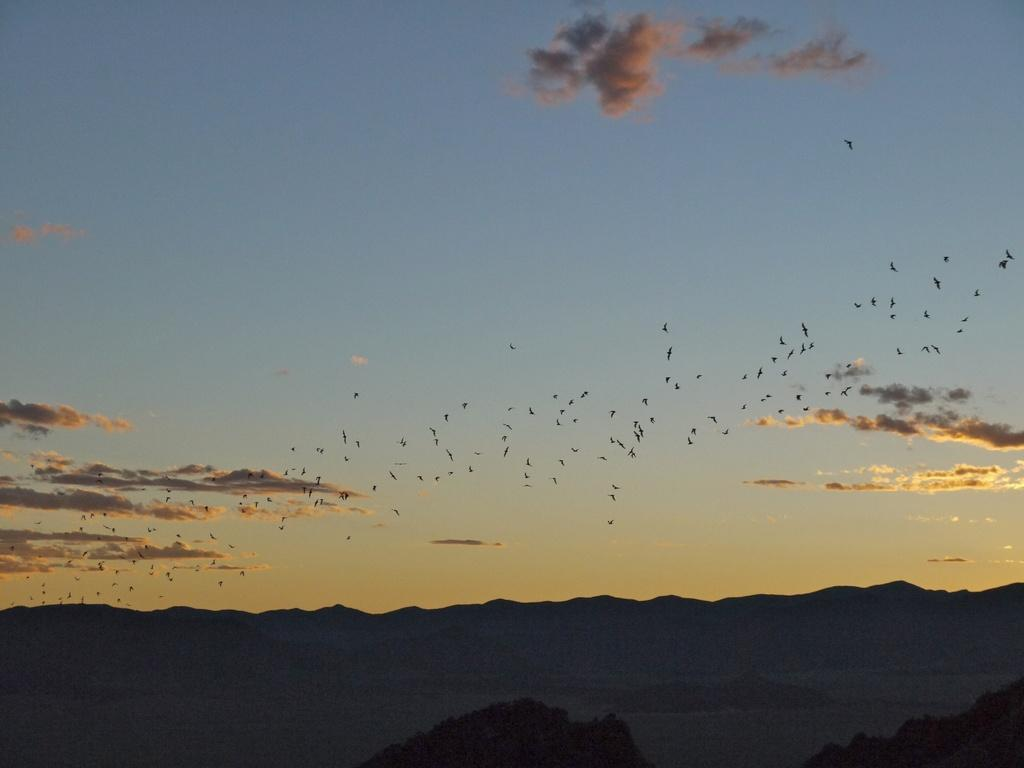What is happening in the sky in the image? The sky is clear in the image. What type of animals can be seen in the image? There are birds flying in the image. What natural features are visible in the image? There are mountains and trees in the image. Where is the tent located in the image? There is no tent present in the image. What type of sea creatures can be seen in the image? There is no sea or sea creatures present in the image. 